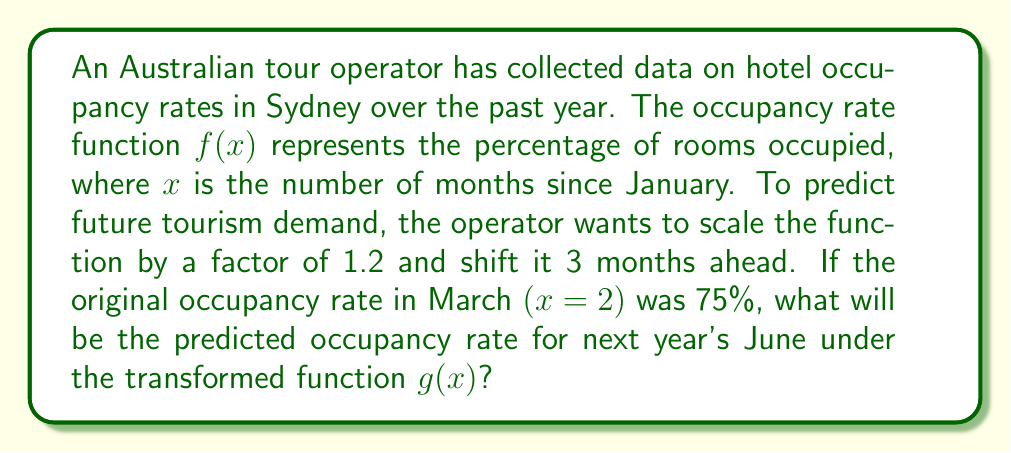What is the answer to this math problem? 1) The original function is $f(x)$, and we're given that $f(2) = 75\%$.

2) The new function $g(x)$ is a transformation of $f(x)$:
   $g(x) = 1.2f(x-3)$

3) We need to find $g(5)$, as June is the 5th month (counting from 0 for January).

4) Substituting into the transformation equation:
   $g(5) = 1.2f(5-3) = 1.2f(2)$

5) We know that $f(2) = 75\%$, so:
   $g(5) = 1.2 \times 75\%$

6) Calculate:
   $g(5) = 1.2 \times 75\% = 0.9 = 90\%$

Therefore, the predicted occupancy rate for next year's June is 90%.
Answer: 90% 